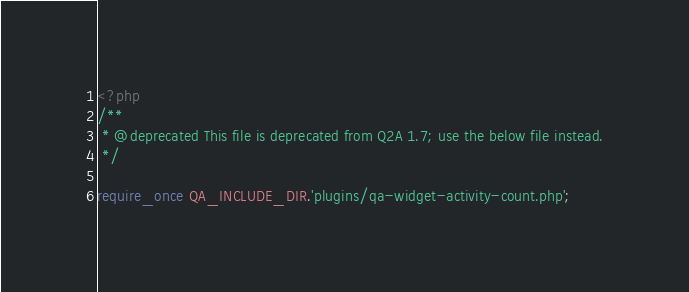<code> <loc_0><loc_0><loc_500><loc_500><_PHP_><?php
/**
 * @deprecated This file is deprecated from Q2A 1.7; use the below file instead.
 */

require_once QA_INCLUDE_DIR.'plugins/qa-widget-activity-count.php';
</code> 